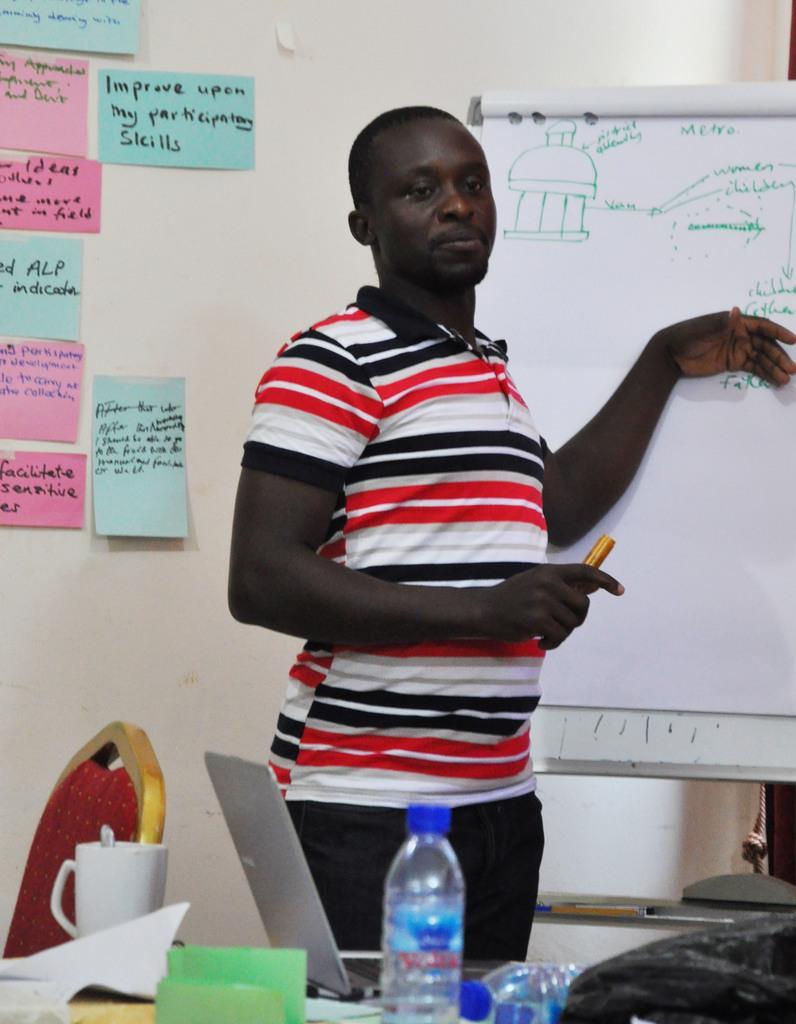Could you give a brief overview of what you see in this image? In this image I can see a person standing. In front of that person there is laptop,bottle ,cup and some of the objects on the table. To the left of that person there is a board and the wall. 